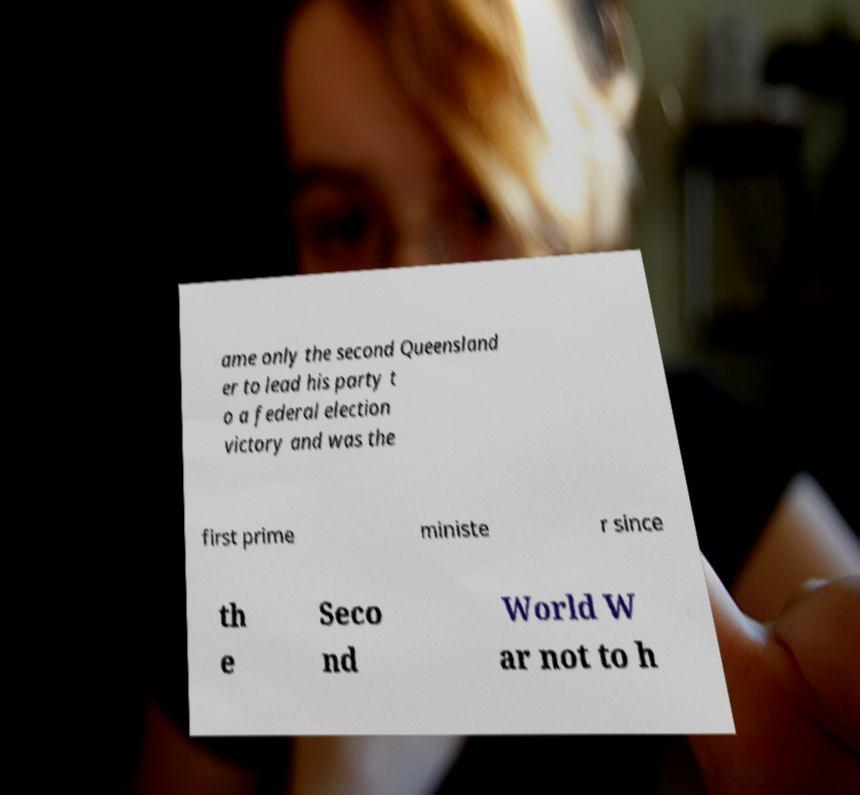Please identify and transcribe the text found in this image. ame only the second Queensland er to lead his party t o a federal election victory and was the first prime ministe r since th e Seco nd World W ar not to h 